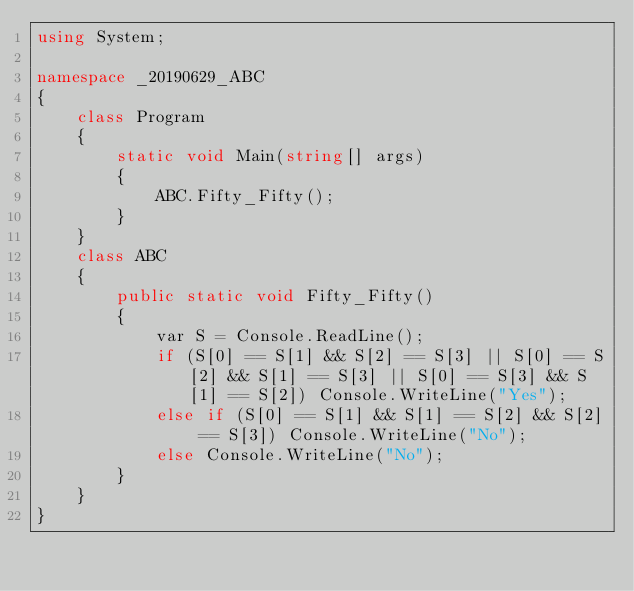<code> <loc_0><loc_0><loc_500><loc_500><_C#_>using System;

namespace _20190629_ABC
{
    class Program
    {
        static void Main(string[] args)
        {
            ABC.Fifty_Fifty();
        }
    }
    class ABC
    {
        public static void Fifty_Fifty()
        {
            var S = Console.ReadLine();
            if (S[0] == S[1] && S[2] == S[3] || S[0] == S[2] && S[1] == S[3] || S[0] == S[3] && S[1] == S[2]) Console.WriteLine("Yes");
            else if (S[0] == S[1] && S[1] == S[2] && S[2] == S[3]) Console.WriteLine("No");
            else Console.WriteLine("No");
        }
    }
}</code> 